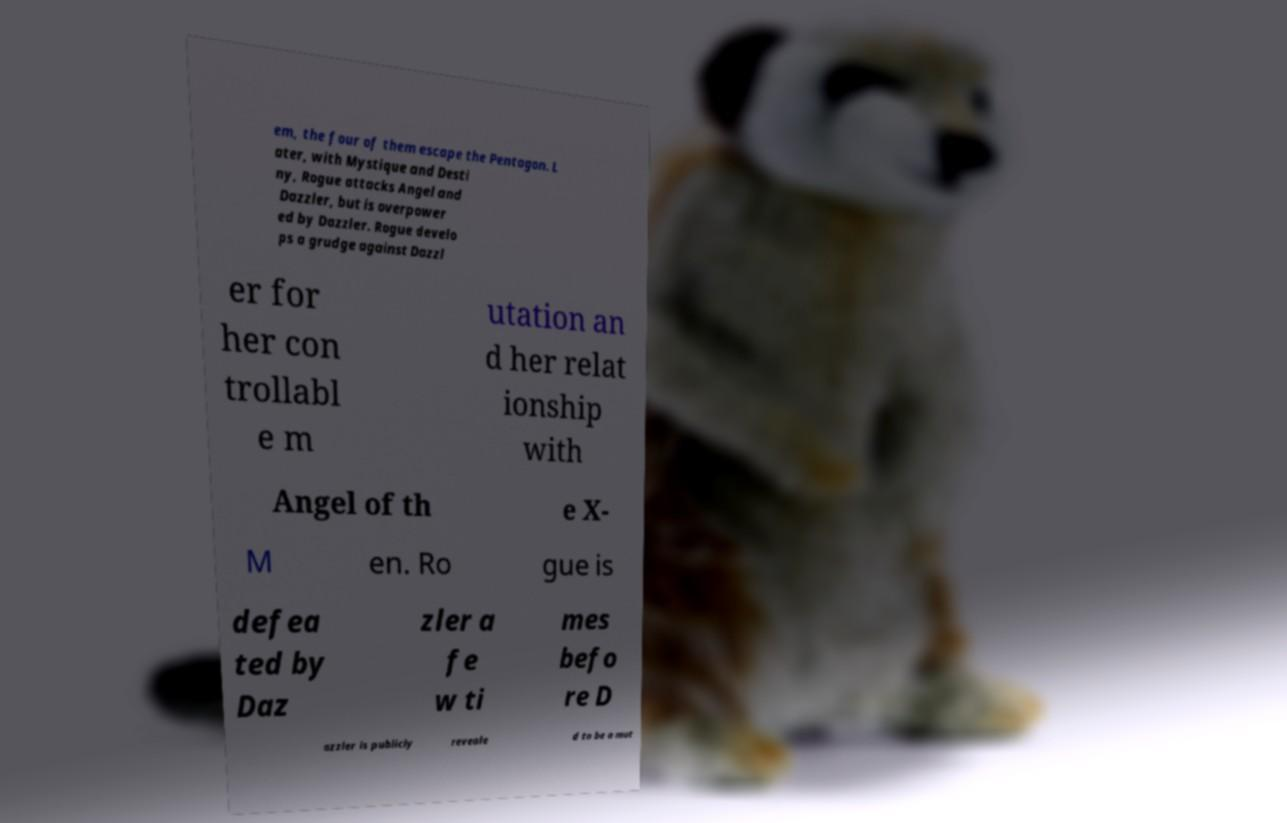Could you assist in decoding the text presented in this image and type it out clearly? em, the four of them escape the Pentagon. L ater, with Mystique and Desti ny, Rogue attacks Angel and Dazzler, but is overpower ed by Dazzler. Rogue develo ps a grudge against Dazzl er for her con trollabl e m utation an d her relat ionship with Angel of th e X- M en. Ro gue is defea ted by Daz zler a fe w ti mes befo re D azzler is publicly reveale d to be a mut 